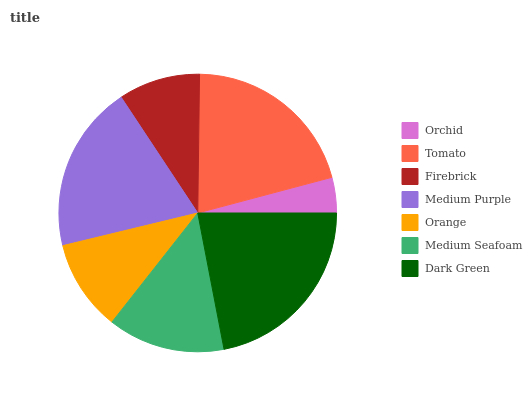Is Orchid the minimum?
Answer yes or no. Yes. Is Dark Green the maximum?
Answer yes or no. Yes. Is Tomato the minimum?
Answer yes or no. No. Is Tomato the maximum?
Answer yes or no. No. Is Tomato greater than Orchid?
Answer yes or no. Yes. Is Orchid less than Tomato?
Answer yes or no. Yes. Is Orchid greater than Tomato?
Answer yes or no. No. Is Tomato less than Orchid?
Answer yes or no. No. Is Medium Seafoam the high median?
Answer yes or no. Yes. Is Medium Seafoam the low median?
Answer yes or no. Yes. Is Firebrick the high median?
Answer yes or no. No. Is Firebrick the low median?
Answer yes or no. No. 